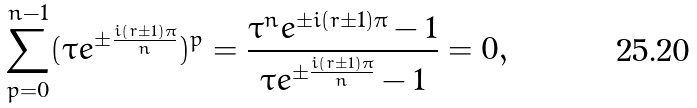<formula> <loc_0><loc_0><loc_500><loc_500>\sum _ { p = 0 } ^ { n - 1 } ( \tau e ^ { \pm \frac { i ( r \pm 1 ) \pi } { n } } ) ^ { p } = \frac { \tau ^ { n } e ^ { \pm i ( r \pm 1 ) \pi } - 1 } { \tau e ^ { \pm \frac { i ( r \pm 1 ) \pi } { n } } - 1 } = 0 ,</formula> 